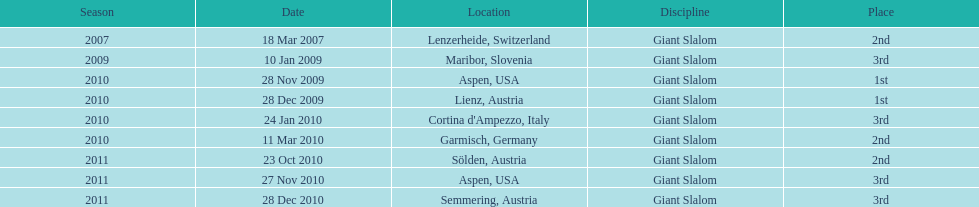Could you parse the entire table as a dict? {'header': ['Season', 'Date', 'Location', 'Discipline', 'Place'], 'rows': [['2007', '18 Mar 2007', 'Lenzerheide, Switzerland', 'Giant Slalom', '2nd'], ['2009', '10 Jan 2009', 'Maribor, Slovenia', 'Giant Slalom', '3rd'], ['2010', '28 Nov 2009', 'Aspen, USA', 'Giant Slalom', '1st'], ['2010', '28 Dec 2009', 'Lienz, Austria', 'Giant Slalom', '1st'], ['2010', '24 Jan 2010', "Cortina d'Ampezzo, Italy", 'Giant Slalom', '3rd'], ['2010', '11 Mar 2010', 'Garmisch, Germany', 'Giant Slalom', '2nd'], ['2011', '23 Oct 2010', 'Sölden, Austria', 'Giant Slalom', '2nd'], ['2011', '27 Nov 2010', 'Aspen, USA', 'Giant Slalom', '3rd'], ['2011', '28 Dec 2010', 'Semmering, Austria', 'Giant Slalom', '3rd']]} In the final race, if they didn't secure the 1st position, which other place did they end up in? 3rd. 